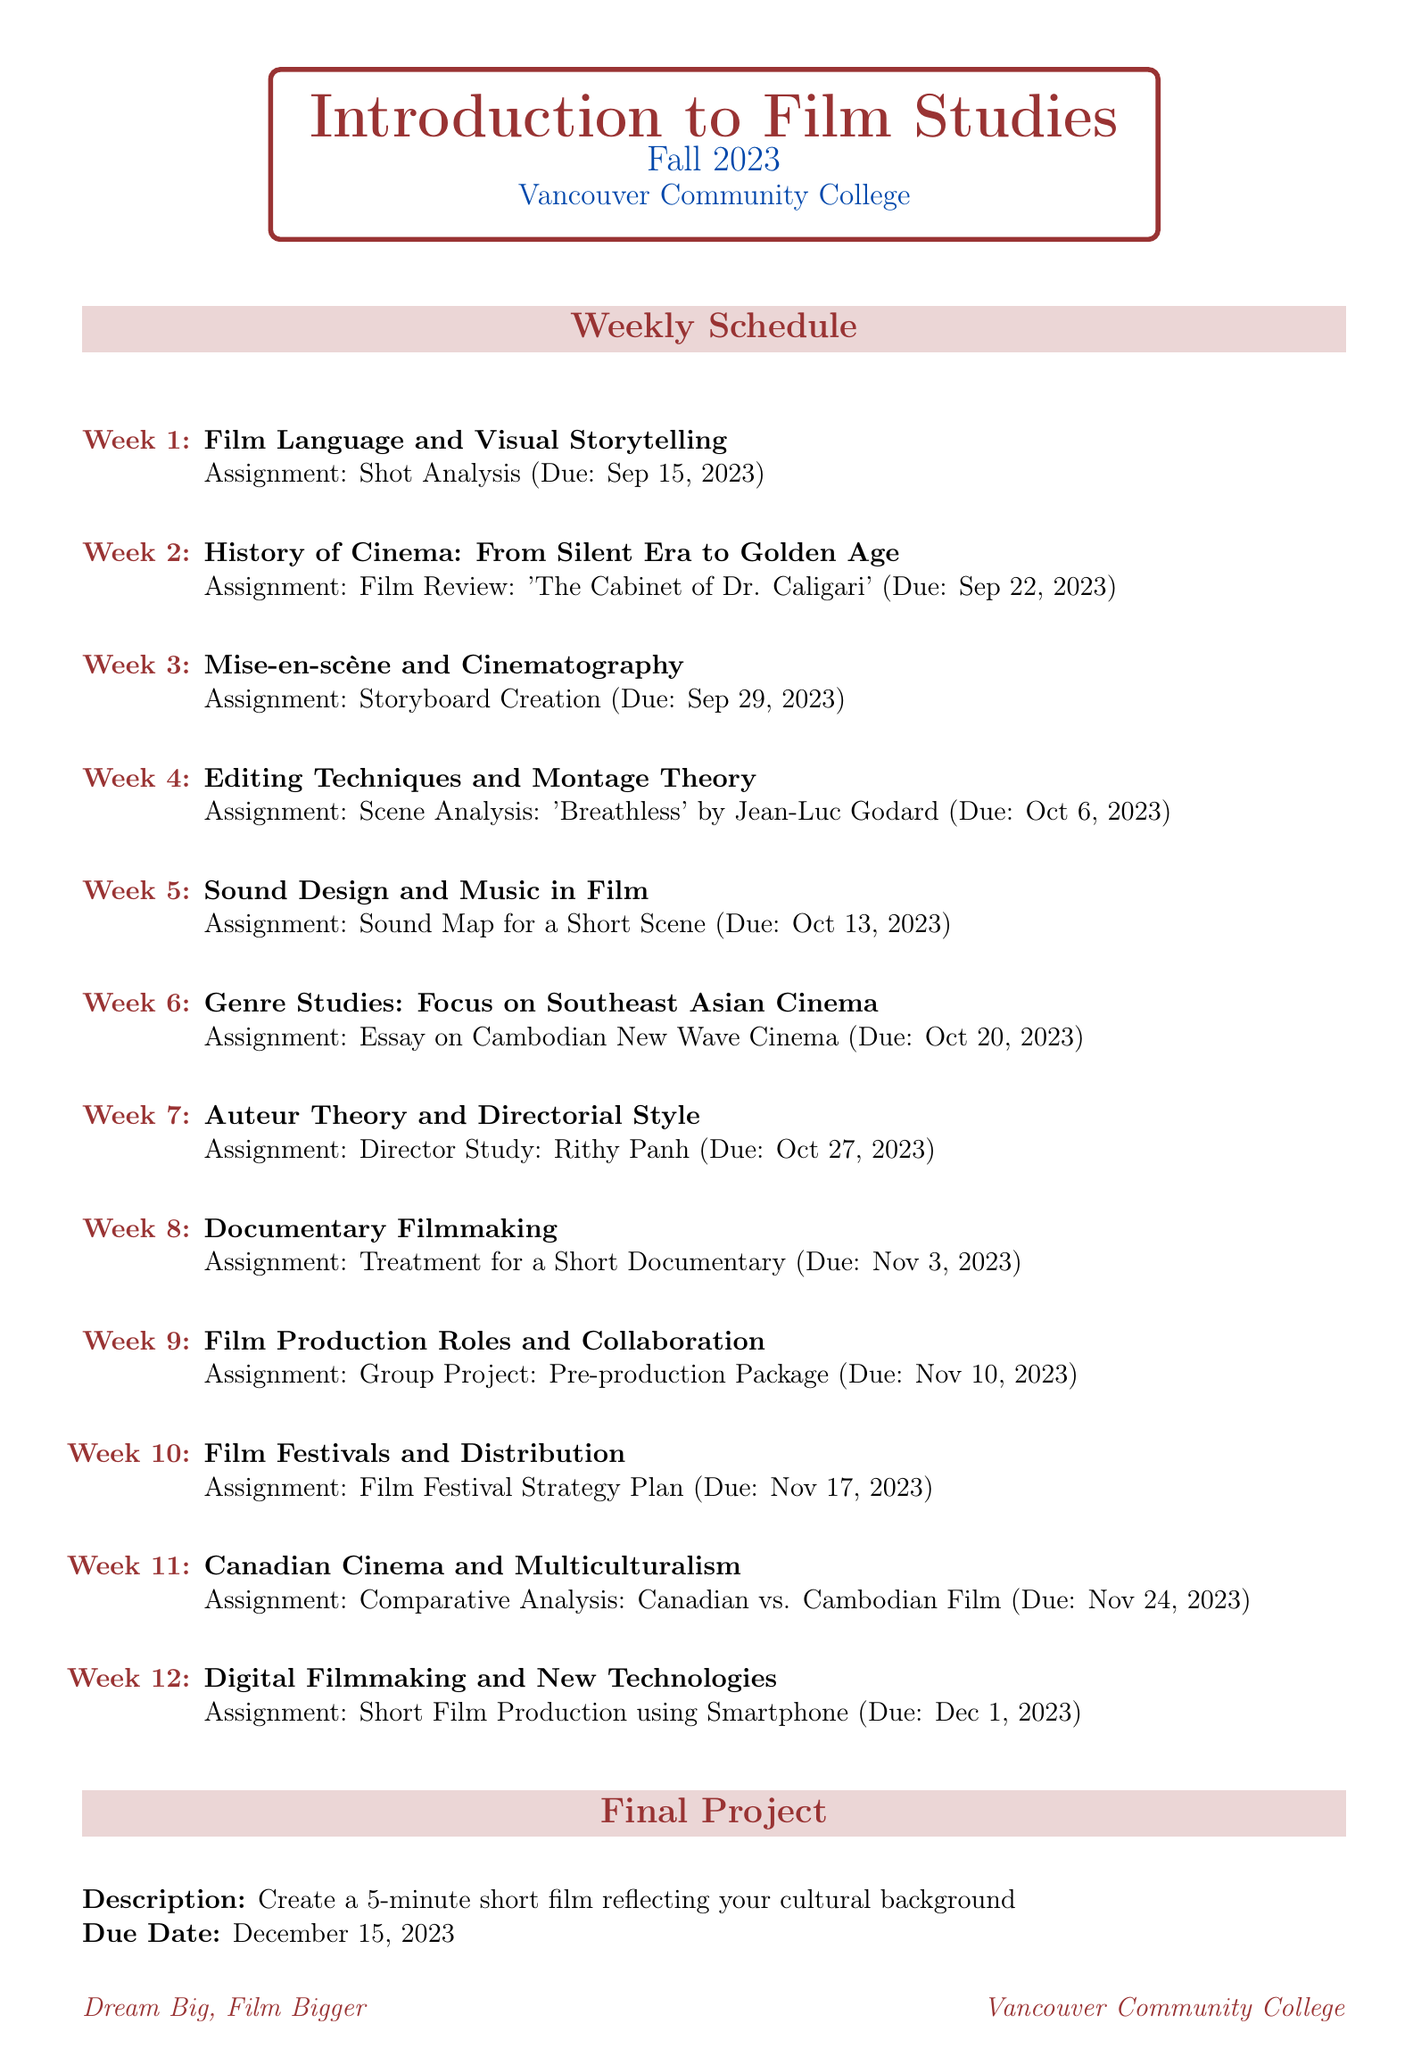What is the course name? The course name is explicitly stated in the document as the title of the class.
Answer: Introduction to Film Studies What is the assignment due in week 5? The document specifies the assignment for each week along with its due date.
Answer: Sound Map for a Short Scene When is the final project due? The due date for the final project is clearly mentioned in the document.
Answer: December 15, 2023 Which week focuses on Southeast Asian Cinema? The specific week and topic are listed in the weekly classes section, indicating the focus on Southeast Asian Cinema.
Answer: Week 6 What is the recommended resource by Mark Cousins? The document lists books and resources, and one is authored by Mark Cousins that can easily be identified.
Answer: The Story of Film What is the topic for week 3? The topic for each week is mentioned in the weekly schedule section, providing the necessary information for this inquiry.
Answer: Mise-en-scène and Cinematography How many assignments are due before November? The weekly schedule indicates the assignments along with their due dates, allowing for a count of those due before November.
Answer: 6 Which festival specifically features Cambodian films? The local film events listed in the document include the name of the festival focusing on Cambodian films.
Answer: Cambodian Film Festival of British Columbia 